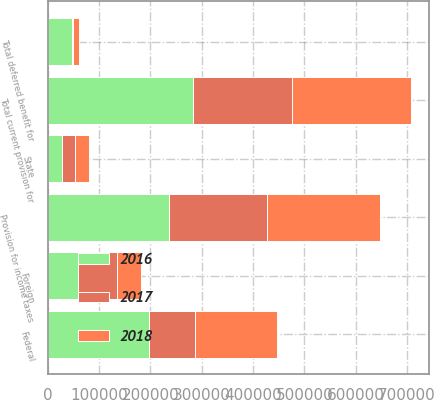Convert chart to OTSL. <chart><loc_0><loc_0><loc_500><loc_500><stacked_bar_chart><ecel><fcel>Federal<fcel>State<fcel>Foreign<fcel>Total current provision for<fcel>Total deferred benefit for<fcel>Provision for income taxes<nl><fcel>2017<fcel>90216<fcel>25851<fcel>77508<fcel>193575<fcel>2180<fcel>191395<nl><fcel>2016<fcel>196825<fcel>27149<fcel>58123<fcel>282097<fcel>46537<fcel>235560<nl><fcel>2018<fcel>159547<fcel>27120<fcel>45545<fcel>232212<fcel>11646<fcel>220566<nl></chart> 